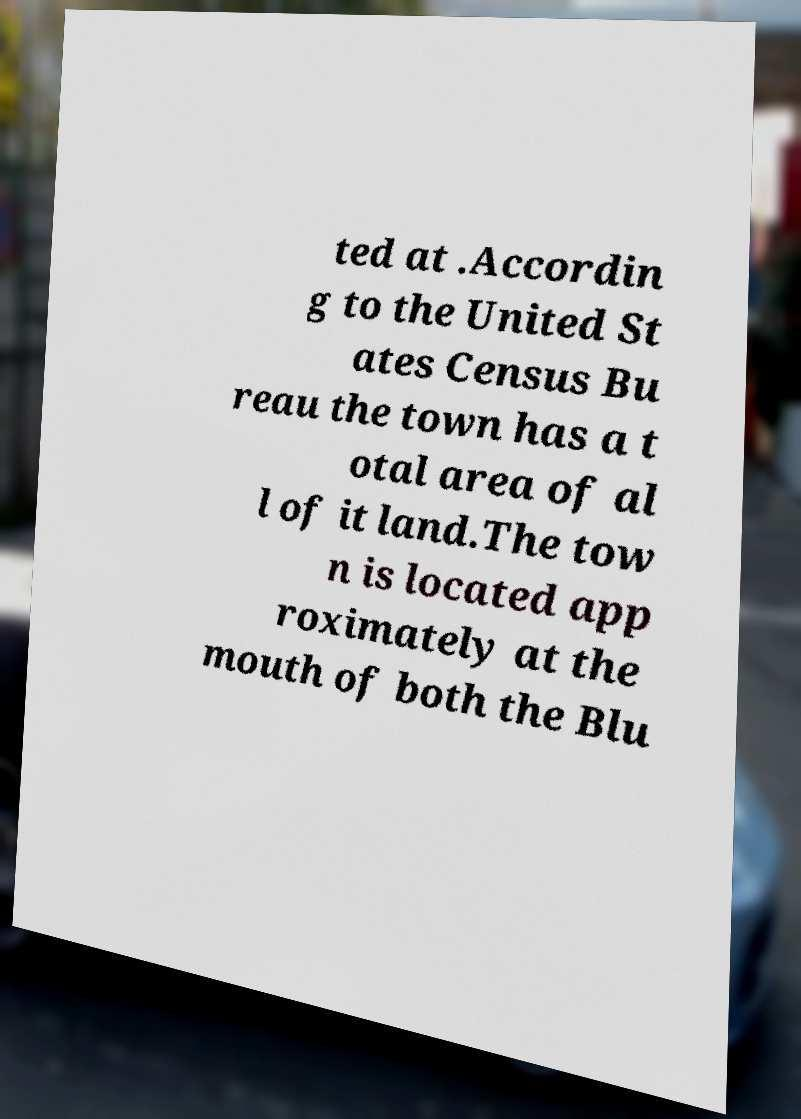There's text embedded in this image that I need extracted. Can you transcribe it verbatim? ted at .Accordin g to the United St ates Census Bu reau the town has a t otal area of al l of it land.The tow n is located app roximately at the mouth of both the Blu 